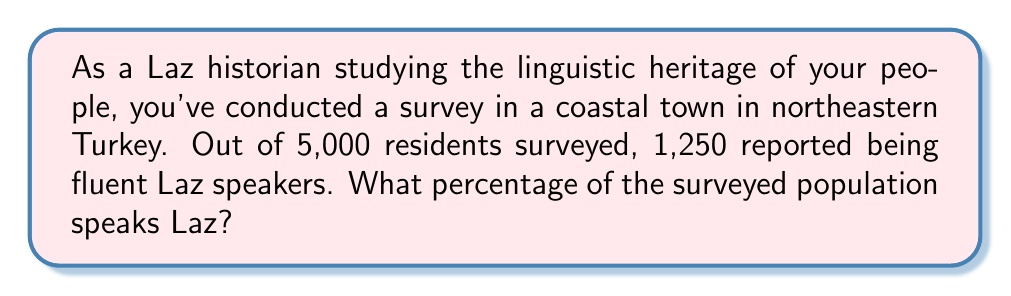Can you solve this math problem? To calculate the percentage of Laz speakers in the surveyed population, we need to use the formula:

$$ \text{Percentage} = \frac{\text{Number of Laz speakers}}{\text{Total population surveyed}} \times 100\% $$

Let's plug in the values we know:
- Number of Laz speakers: 1,250
- Total population surveyed: 5,000

$$ \text{Percentage} = \frac{1,250}{5,000} \times 100\% $$

Now, let's solve this step-by-step:

1) First, divide 1,250 by 5,000:
   $$ \frac{1,250}{5,000} = 0.25 $$

2) Then, multiply by 100 to convert to a percentage:
   $$ 0.25 \times 100\% = 25\% $$

Therefore, 25% of the surveyed population speaks Laz.
Answer: 25% 